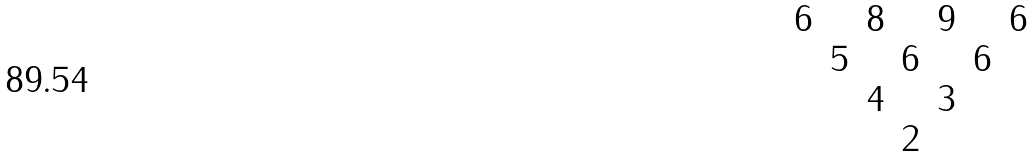Convert formula to latex. <formula><loc_0><loc_0><loc_500><loc_500>\begin{matrix} 6 & & 8 & & 9 & & 6 \\ & 5 & & 6 & & 6 \\ & & 4 & & 3 \\ & & & 2 \end{matrix}</formula> 